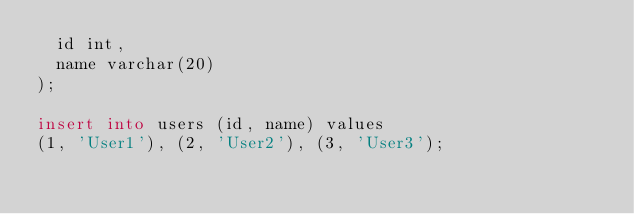<code> <loc_0><loc_0><loc_500><loc_500><_SQL_>  id int,
  name varchar(20)
);

insert into users (id, name) values
(1, 'User1'), (2, 'User2'), (3, 'User3');</code> 